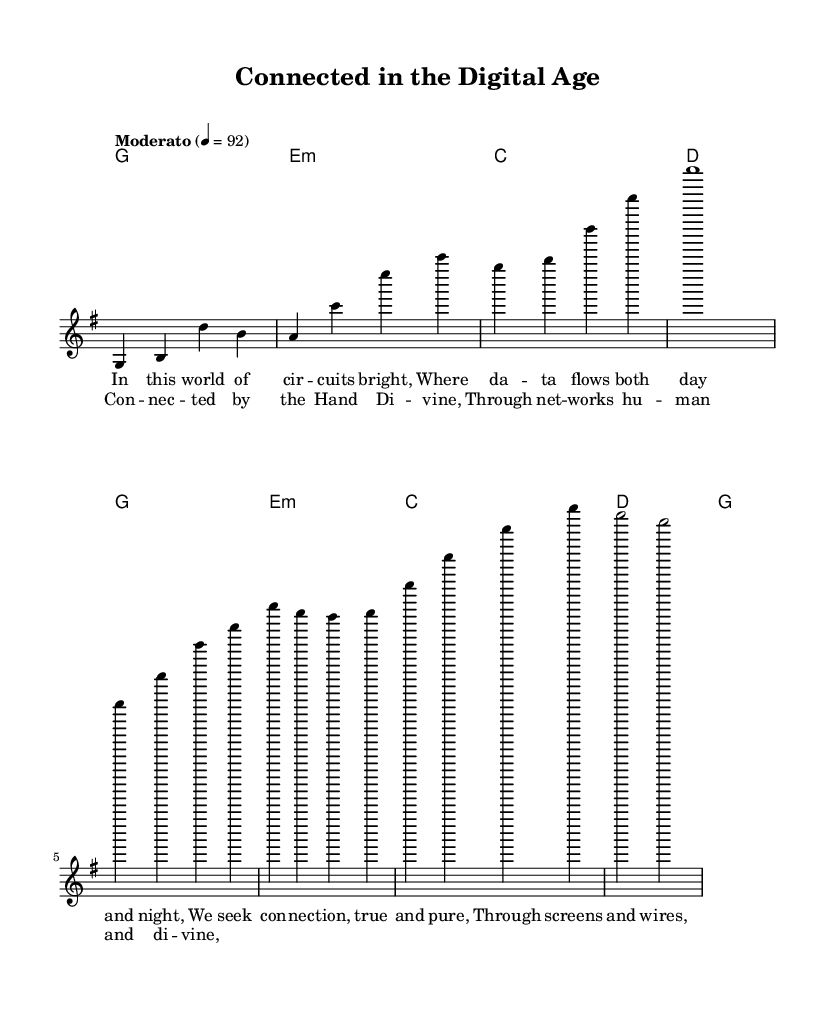What is the key signature of this music? The key signature displayed in the sheet music is G major, which has one sharp (F#). This information is generally found at the beginning of the staff, indicating it is in the key of G major.
Answer: G major What is the time signature of this music? The time signature visible in the sheet music is 4/4. This can be identified by looking at the notation at the beginning of the piece before the melodic and harmonic staves.
Answer: 4/4 What is the tempo marking for this piece? The tempo marking is indicated as "Moderato," where a specific tempo of 92 beats per minute is noted. This provides the performer with guidance on the speed of the music.
Answer: Moderato How many verses are present in this piece? The sheet music presents one verse along with a repeated chorus. This can be deduced from the structure shown in the lyrics section of the score.
Answer: One What is the primary theme expressed in the lyrics? The lyrics express the theme of human connectivity and divine connection in the context of modern technology. The phrases indicate an exploration of bonds formed through digital means.
Answer: Connectivity What type of musical form is used in this hymn? The hymn follows a verse-chorus structure, typical in modern religious music, where a main theme is introduced and then revisited in the form of a chorus after the verse.
Answer: Verse-chorus 